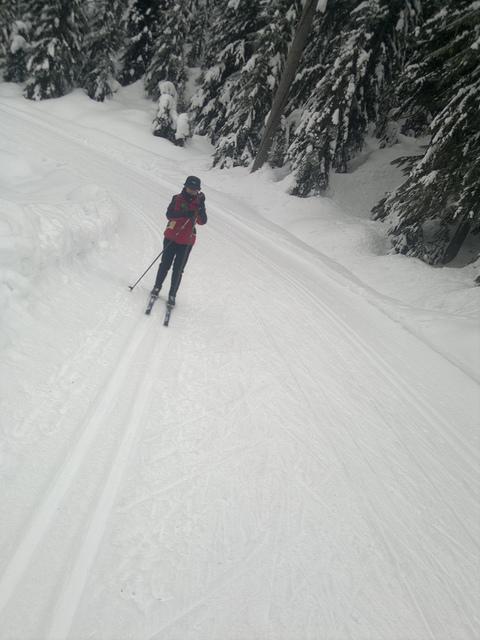Are the skis positioned to speed up or slow down?
Concise answer only. Speed up. What is the person doing?
Answer briefly. Skiing. Is this person skiing?
Give a very brief answer. Yes. What is the man riding on?
Be succinct. Skis. Have any vehicles been on the snow?
Give a very brief answer. No. Are there many people on the mountain?
Be succinct. No. Is this person snowboarding?
Keep it brief. No. Are the trees evergreen?
Concise answer only. Yes. What is the person in front looking at?
Be succinct. Trees. 